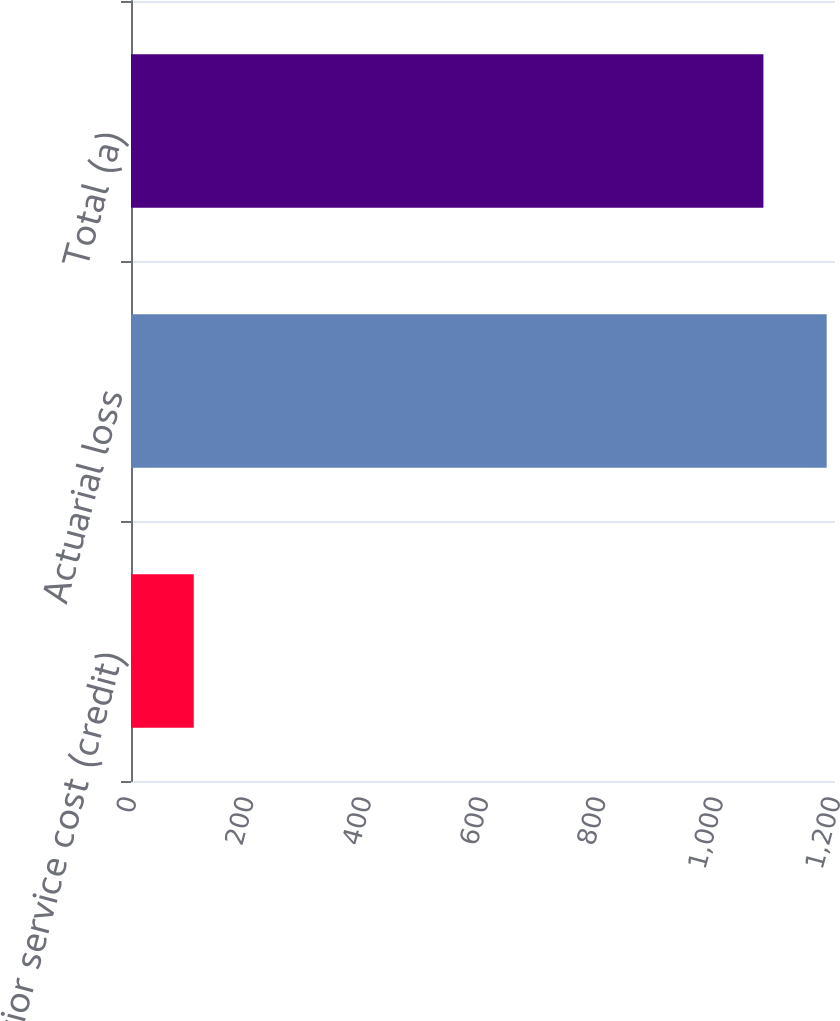<chart> <loc_0><loc_0><loc_500><loc_500><bar_chart><fcel>Prior service cost (credit)<fcel>Actuarial loss<fcel>Total (a)<nl><fcel>107<fcel>1185.8<fcel>1078<nl></chart> 